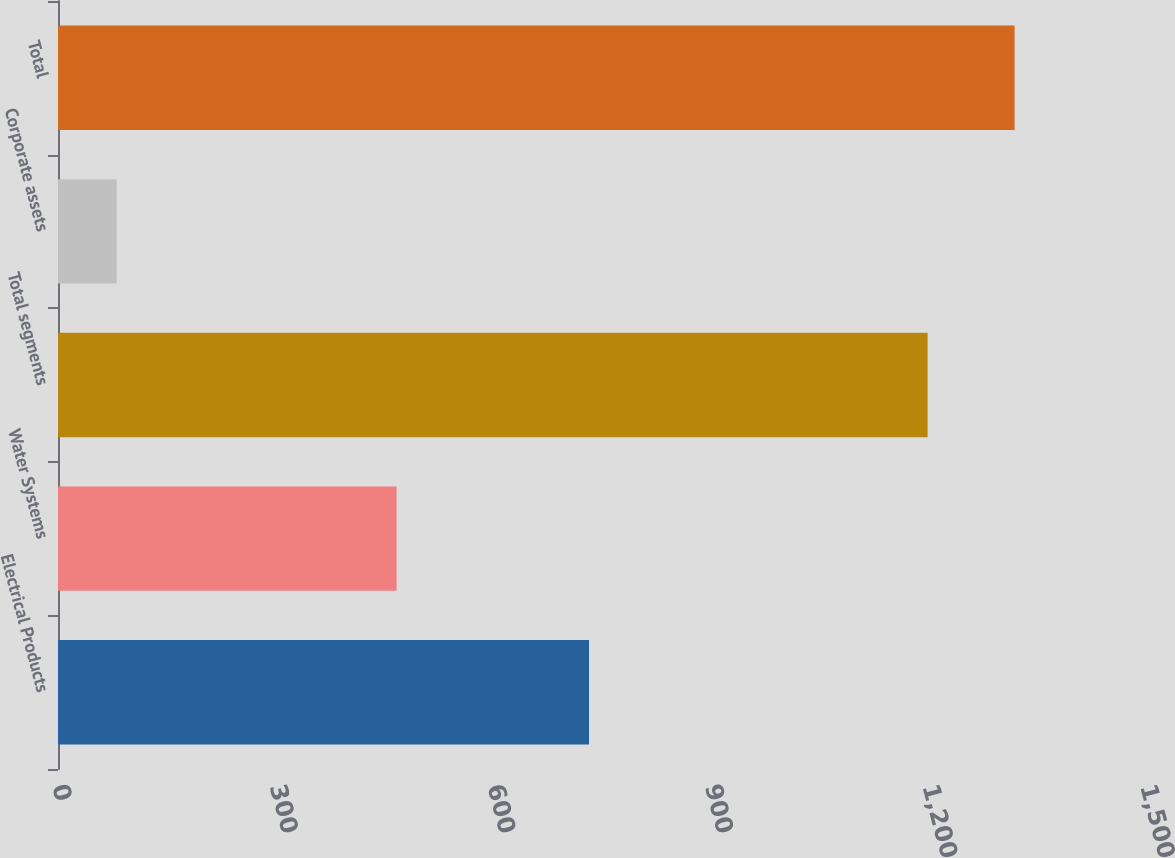<chart> <loc_0><loc_0><loc_500><loc_500><bar_chart><fcel>Electrical Products<fcel>Water Systems<fcel>Total segments<fcel>Corporate assets<fcel>Total<nl><fcel>732.1<fcel>466.8<fcel>1198.9<fcel>81<fcel>1318.79<nl></chart> 